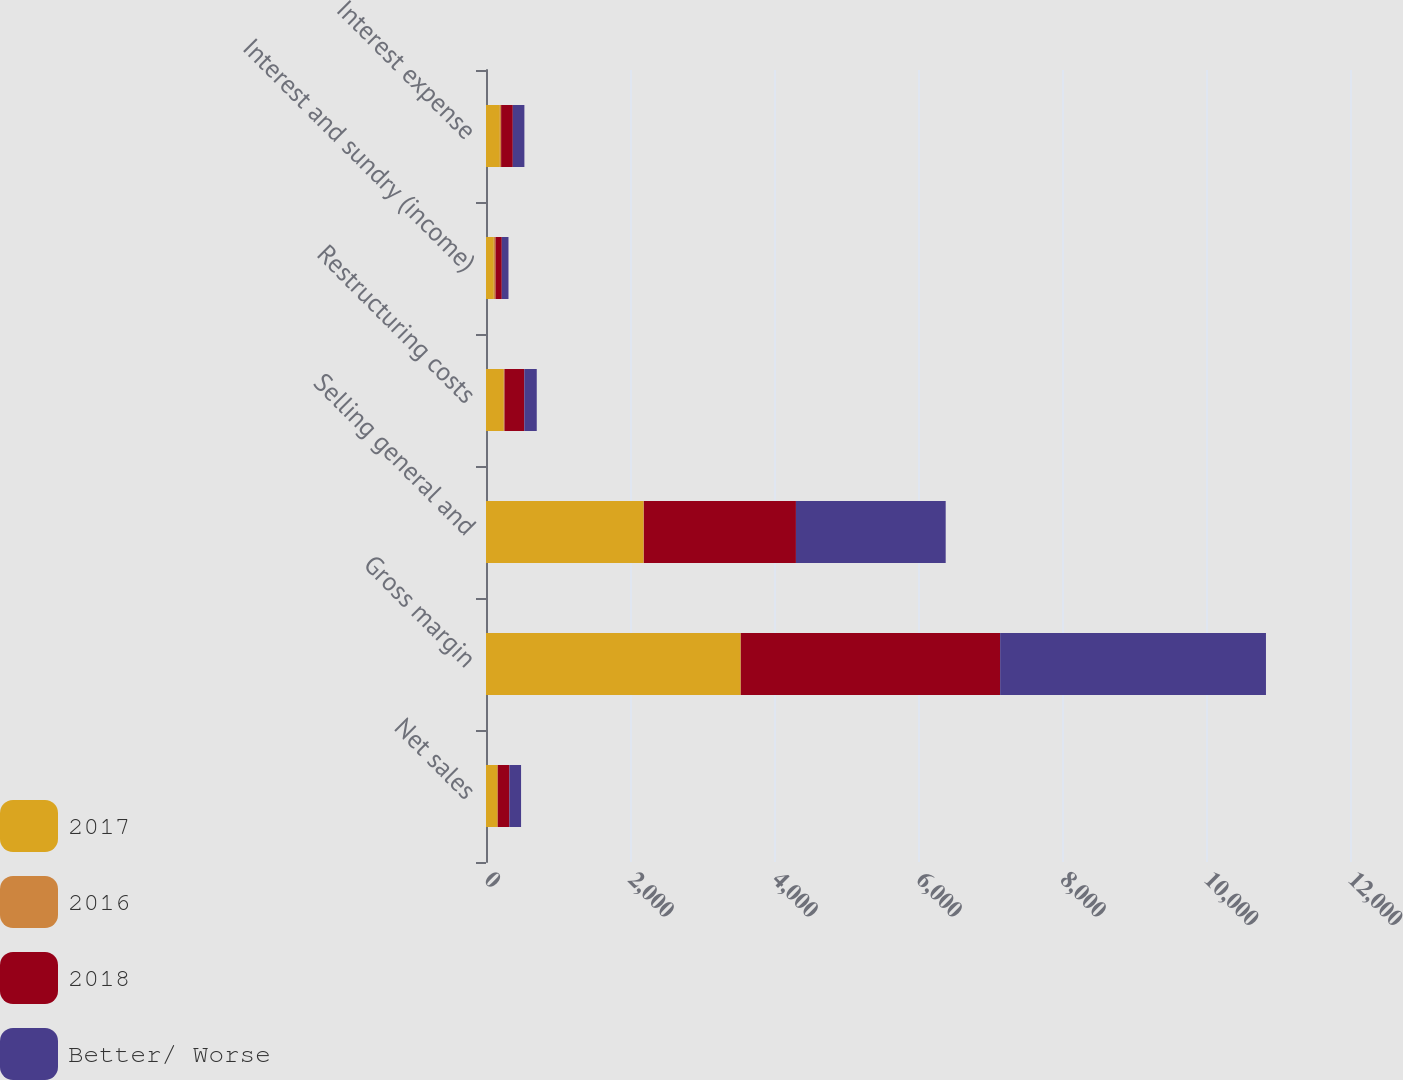Convert chart to OTSL. <chart><loc_0><loc_0><loc_500><loc_500><stacked_bar_chart><ecel><fcel>Net sales<fcel>Gross margin<fcel>Selling general and<fcel>Restructuring costs<fcel>Interest and sundry (income)<fcel>Interest expense<nl><fcel>2017<fcel>162<fcel>3537<fcel>2189<fcel>247<fcel>108<fcel>192<nl><fcel>2016<fcel>1<fcel>1.8<fcel>3.6<fcel>10<fcel>24.3<fcel>18.2<nl><fcel>2018<fcel>162<fcel>3602<fcel>2112<fcel>275<fcel>87<fcel>162<nl><fcel>Better/ Worse<fcel>162<fcel>3692<fcel>2080<fcel>173<fcel>93<fcel>161<nl></chart> 